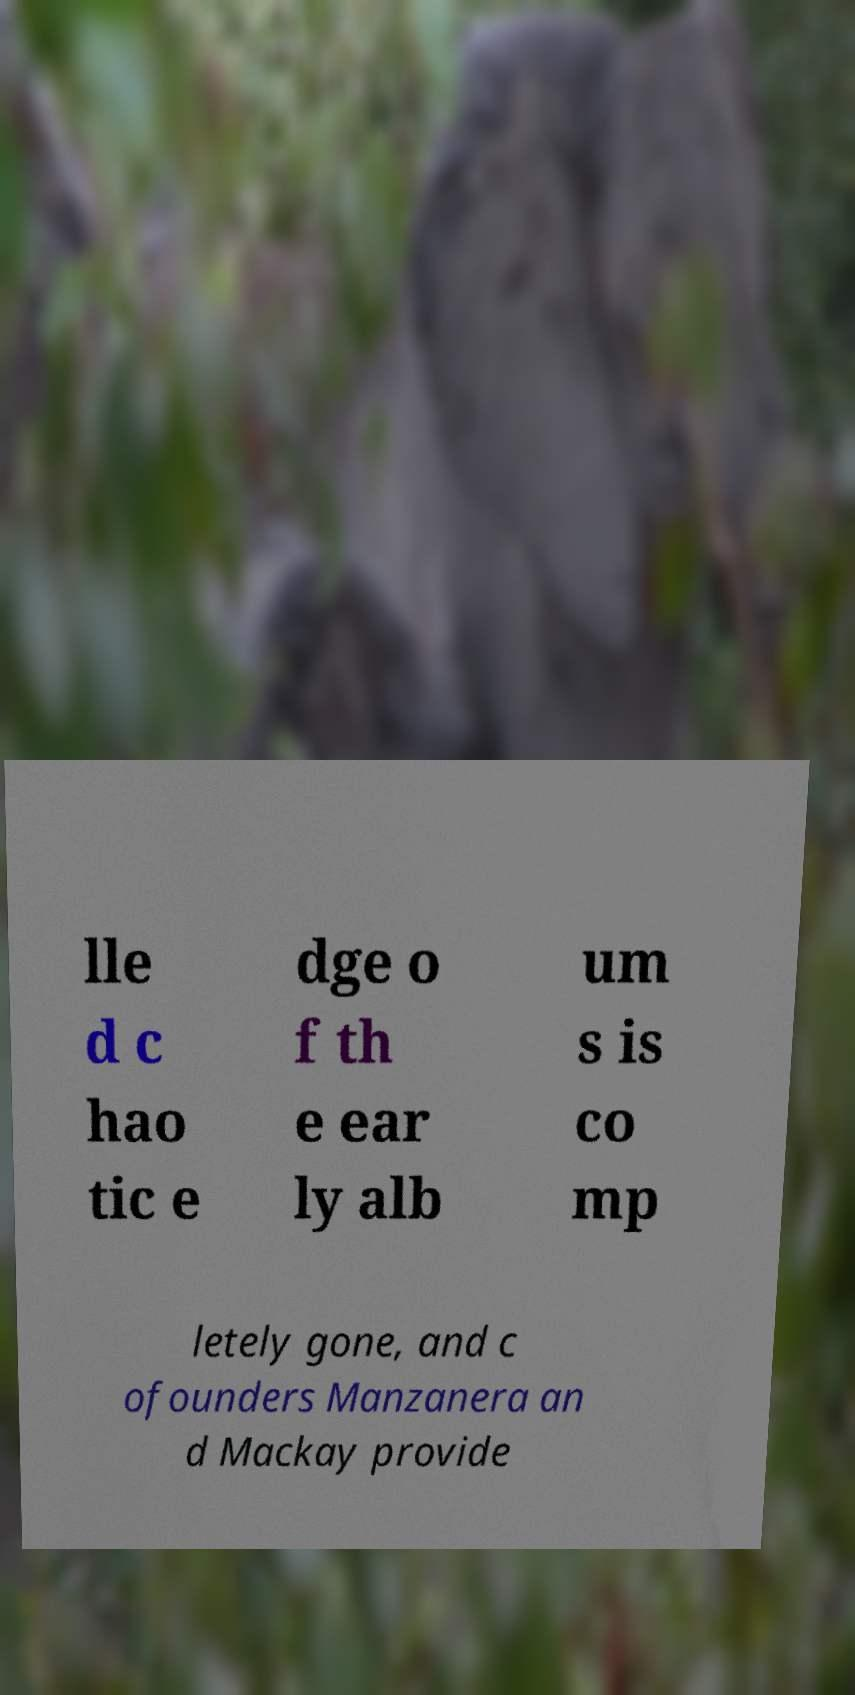There's text embedded in this image that I need extracted. Can you transcribe it verbatim? lle d c hao tic e dge o f th e ear ly alb um s is co mp letely gone, and c ofounders Manzanera an d Mackay provide 